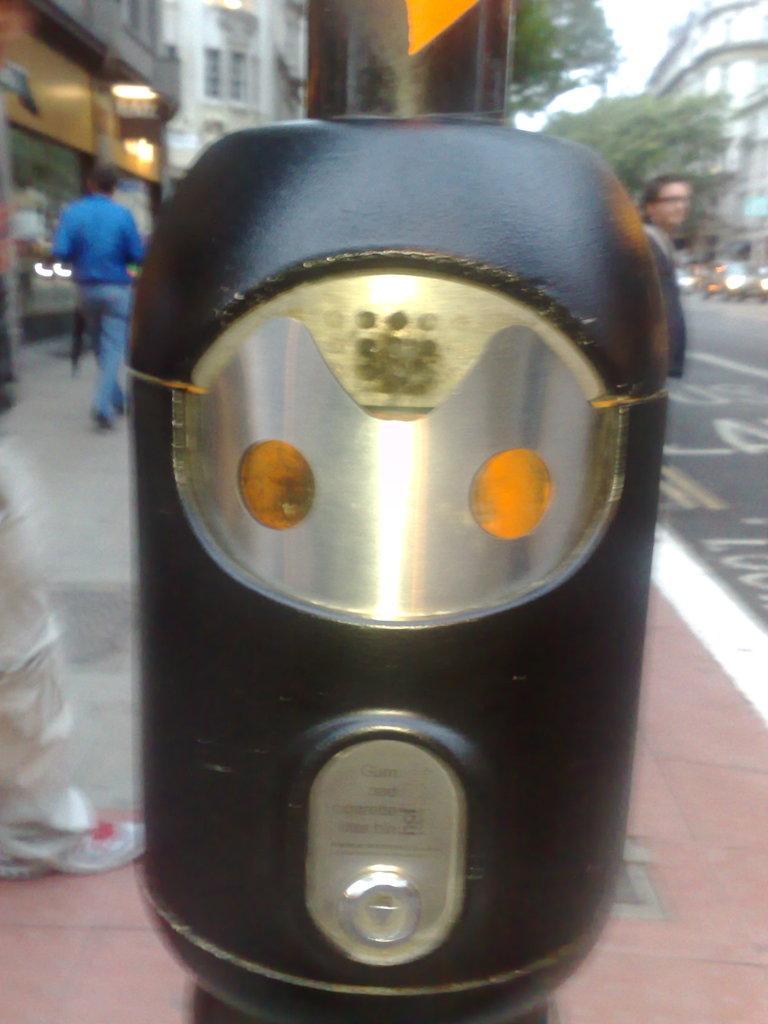Describe this image in one or two sentences. In this image, we can see a black object. Background we can see few people, road, walkway, trees, buildings, vehicles and lights. 